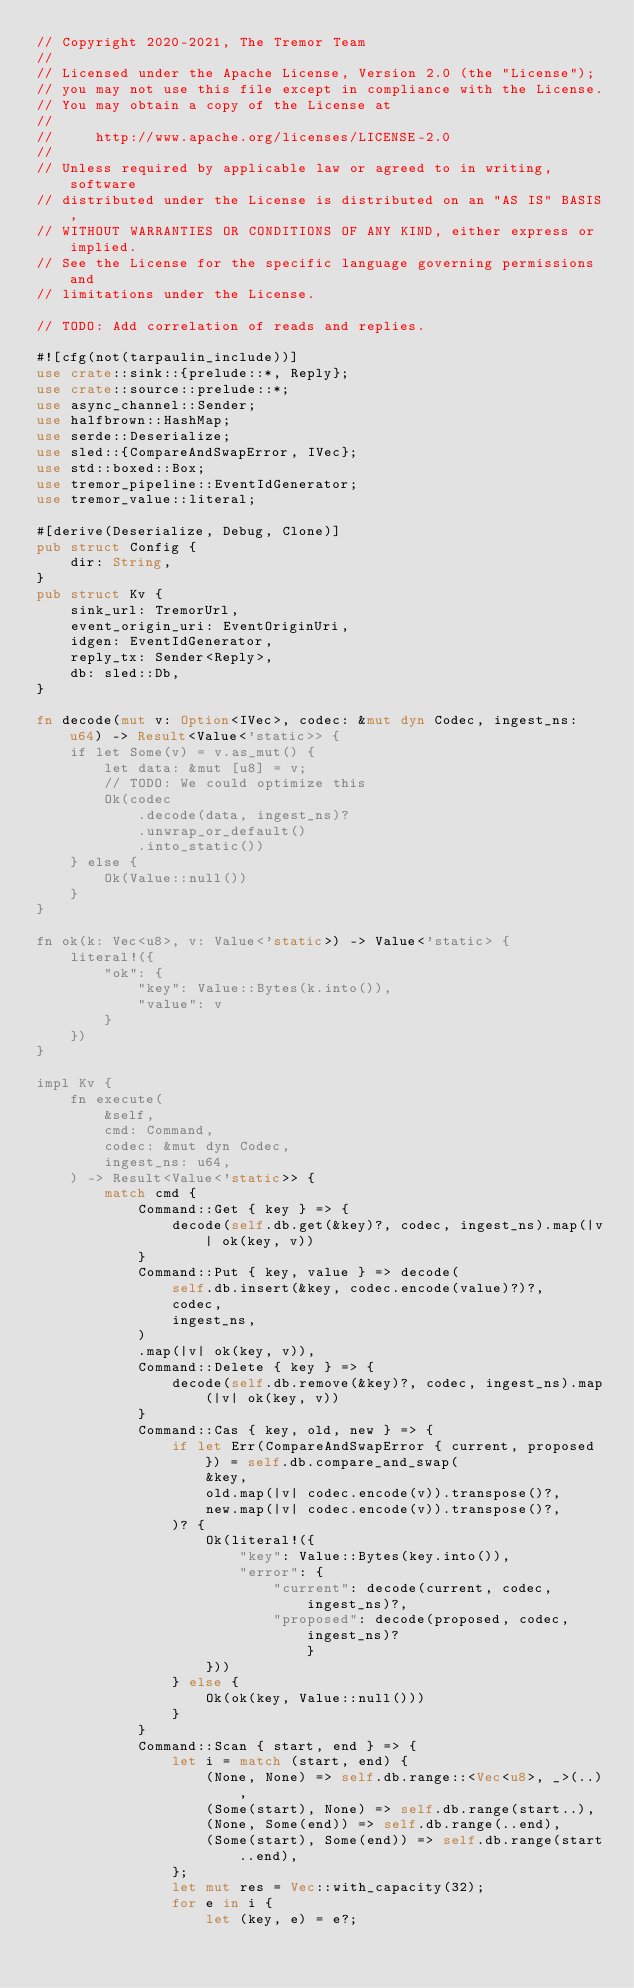<code> <loc_0><loc_0><loc_500><loc_500><_Rust_>// Copyright 2020-2021, The Tremor Team
//
// Licensed under the Apache License, Version 2.0 (the "License");
// you may not use this file except in compliance with the License.
// You may obtain a copy of the License at
//
//     http://www.apache.org/licenses/LICENSE-2.0
//
// Unless required by applicable law or agreed to in writing, software
// distributed under the License is distributed on an "AS IS" BASIS,
// WITHOUT WARRANTIES OR CONDITIONS OF ANY KIND, either express or implied.
// See the License for the specific language governing permissions and
// limitations under the License.

// TODO: Add correlation of reads and replies.

#![cfg(not(tarpaulin_include))]
use crate::sink::{prelude::*, Reply};
use crate::source::prelude::*;
use async_channel::Sender;
use halfbrown::HashMap;
use serde::Deserialize;
use sled::{CompareAndSwapError, IVec};
use std::boxed::Box;
use tremor_pipeline::EventIdGenerator;
use tremor_value::literal;

#[derive(Deserialize, Debug, Clone)]
pub struct Config {
    dir: String,
}
pub struct Kv {
    sink_url: TremorUrl,
    event_origin_uri: EventOriginUri,
    idgen: EventIdGenerator,
    reply_tx: Sender<Reply>,
    db: sled::Db,
}

fn decode(mut v: Option<IVec>, codec: &mut dyn Codec, ingest_ns: u64) -> Result<Value<'static>> {
    if let Some(v) = v.as_mut() {
        let data: &mut [u8] = v;
        // TODO: We could optimize this
        Ok(codec
            .decode(data, ingest_ns)?
            .unwrap_or_default()
            .into_static())
    } else {
        Ok(Value::null())
    }
}

fn ok(k: Vec<u8>, v: Value<'static>) -> Value<'static> {
    literal!({
        "ok": {
            "key": Value::Bytes(k.into()),
            "value": v
        }
    })
}

impl Kv {
    fn execute(
        &self,
        cmd: Command,
        codec: &mut dyn Codec,
        ingest_ns: u64,
    ) -> Result<Value<'static>> {
        match cmd {
            Command::Get { key } => {
                decode(self.db.get(&key)?, codec, ingest_ns).map(|v| ok(key, v))
            }
            Command::Put { key, value } => decode(
                self.db.insert(&key, codec.encode(value)?)?,
                codec,
                ingest_ns,
            )
            .map(|v| ok(key, v)),
            Command::Delete { key } => {
                decode(self.db.remove(&key)?, codec, ingest_ns).map(|v| ok(key, v))
            }
            Command::Cas { key, old, new } => {
                if let Err(CompareAndSwapError { current, proposed }) = self.db.compare_and_swap(
                    &key,
                    old.map(|v| codec.encode(v)).transpose()?,
                    new.map(|v| codec.encode(v)).transpose()?,
                )? {
                    Ok(literal!({
                        "key": Value::Bytes(key.into()),
                        "error": {
                            "current": decode(current, codec, ingest_ns)?,
                            "proposed": decode(proposed, codec, ingest_ns)?                        }
                    }))
                } else {
                    Ok(ok(key, Value::null()))
                }
            }
            Command::Scan { start, end } => {
                let i = match (start, end) {
                    (None, None) => self.db.range::<Vec<u8>, _>(..),
                    (Some(start), None) => self.db.range(start..),
                    (None, Some(end)) => self.db.range(..end),
                    (Some(start), Some(end)) => self.db.range(start..end),
                };
                let mut res = Vec::with_capacity(32);
                for e in i {
                    let (key, e) = e?;</code> 